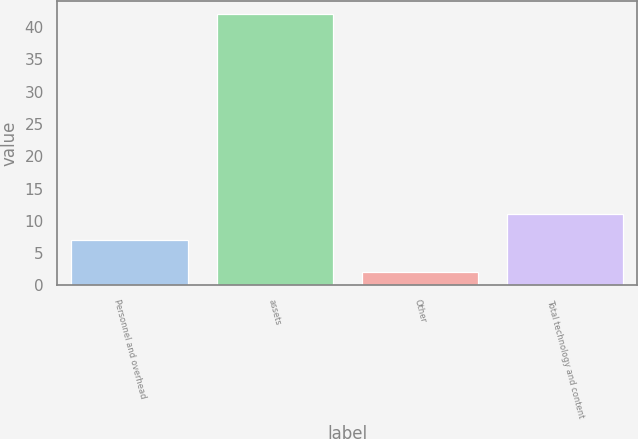Convert chart to OTSL. <chart><loc_0><loc_0><loc_500><loc_500><bar_chart><fcel>Personnel and overhead<fcel>assets<fcel>Other<fcel>Total technology and content<nl><fcel>7<fcel>42<fcel>2<fcel>11<nl></chart> 